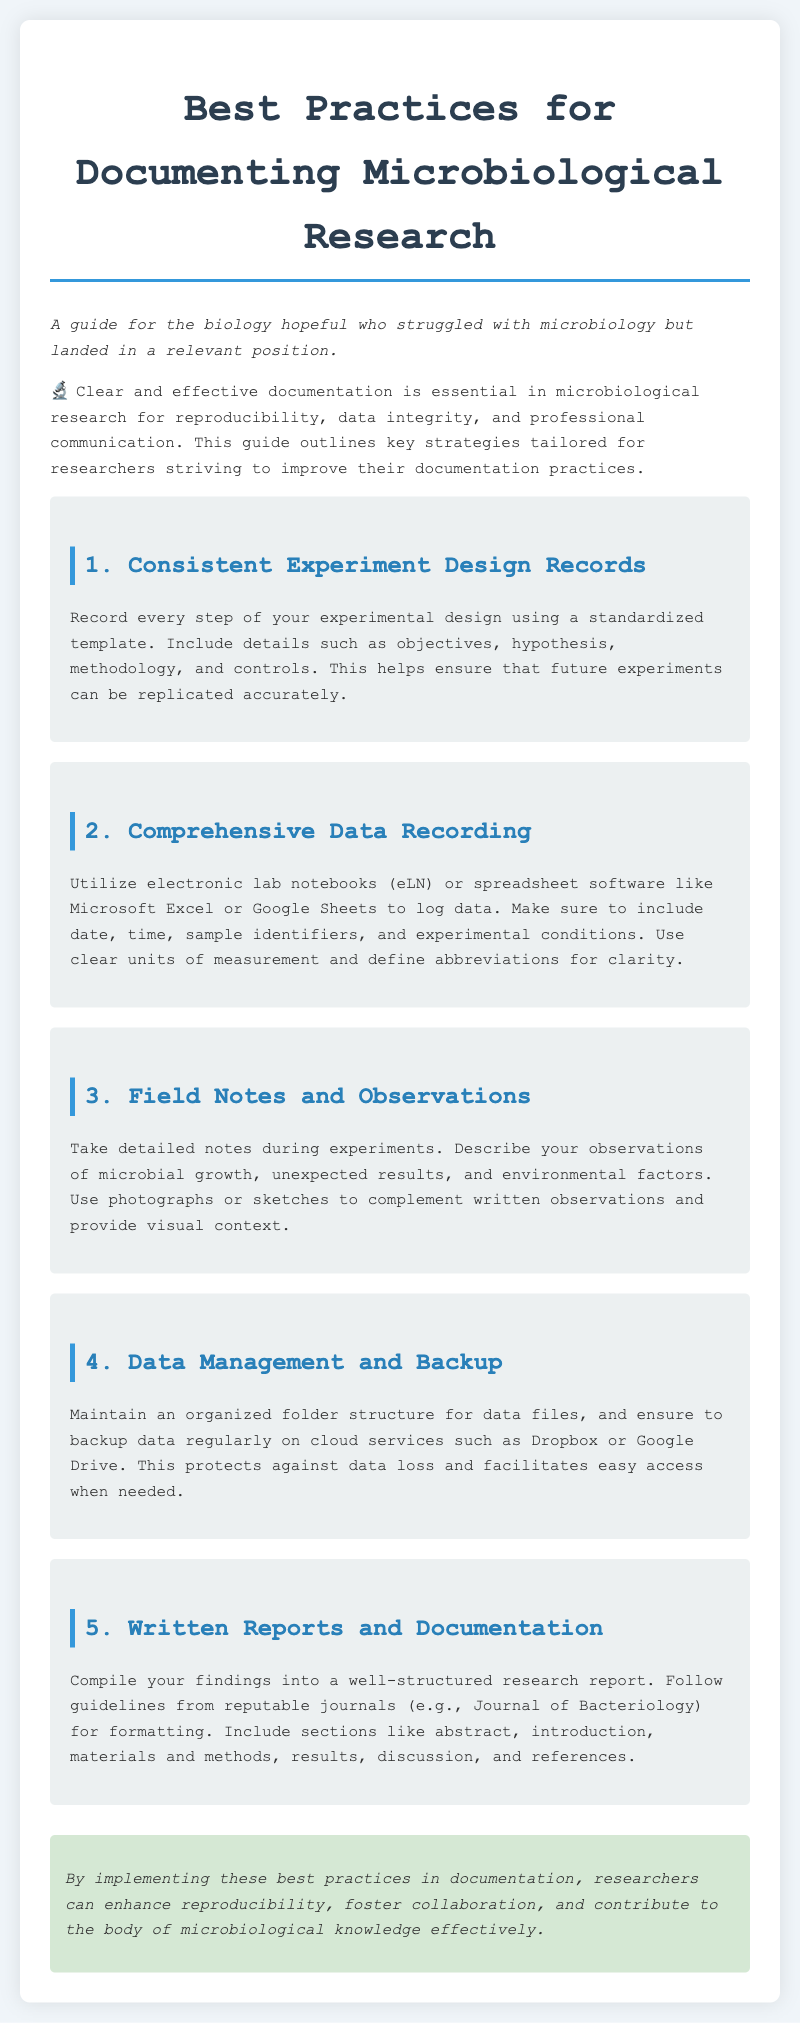What is the title of the document? The title of the document is stated at the top.
Answer: Best Practices for Documenting Microbiological Research How many main sections are in the guide? The number of main sections is listed in the document.
Answer: Five What is the first main section of the guide? The first main section is the title of the section mentioned in the document.
Answer: Consistent Experiment Design Records What should be included in comprehensive data recording? The document specifies what to record under comprehensive data recording.
Answer: Date, time, sample identifiers, and experimental conditions What visual aids can complement written observations? The document suggests certain tools to aid in documentation.
Answer: Photographs or sketches What should be regularly backed up according to the best practices? The guideline emphasizes the importance of a specific data aspect.
Answer: Data What is the purpose of maintaining an organized folder structure? The document states the function of having an organized folder for data.
Answer: Protects against data loss and facilitates easy access Which section discusses the structure of research reports? The section that elaborates on report writing is mentioned in the document.
Answer: Written Reports and Documentation What effect do these documentation practices aim to enhance? The document outlines the main impact of following the practices.
Answer: Reproducibility 